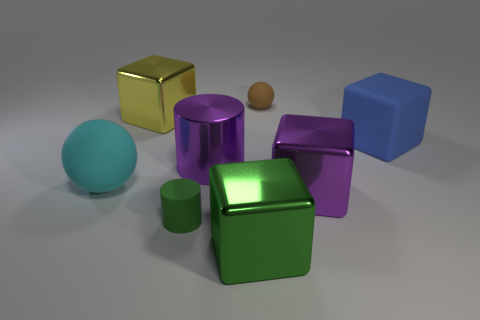Can you describe the texture and appearance of the large yellow object in the foreground? The large yellow object in the foreground has a smooth, shiny surface that reflects the light. Its appearance is consistent with that of a reflective, polished metallic cube. 